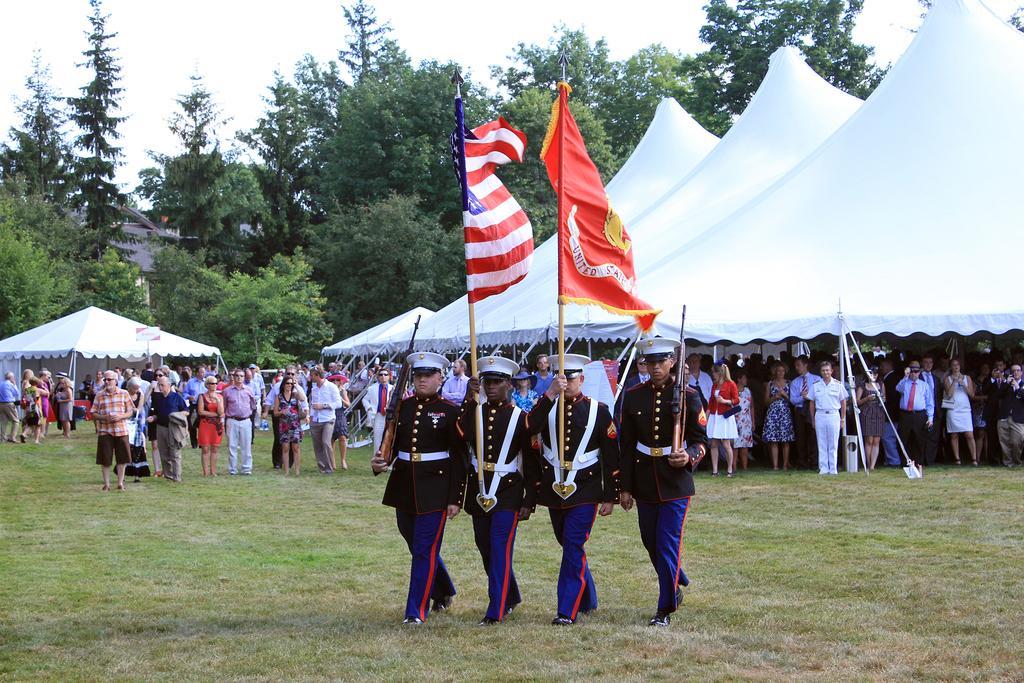Describe this image in one or two sentences. To the bottom of the image there is a ground with the grass. In the middle of the grass there are four man with the black shirts, blue pants and white caps is walking on the grass. The middle two members are holding the flag poles with the flags. And the corner two are holding the guns in their hands. At the back of them there are many people standing. And also there is a white tent. In the background there are trees and to the top of the image there is a sky. 